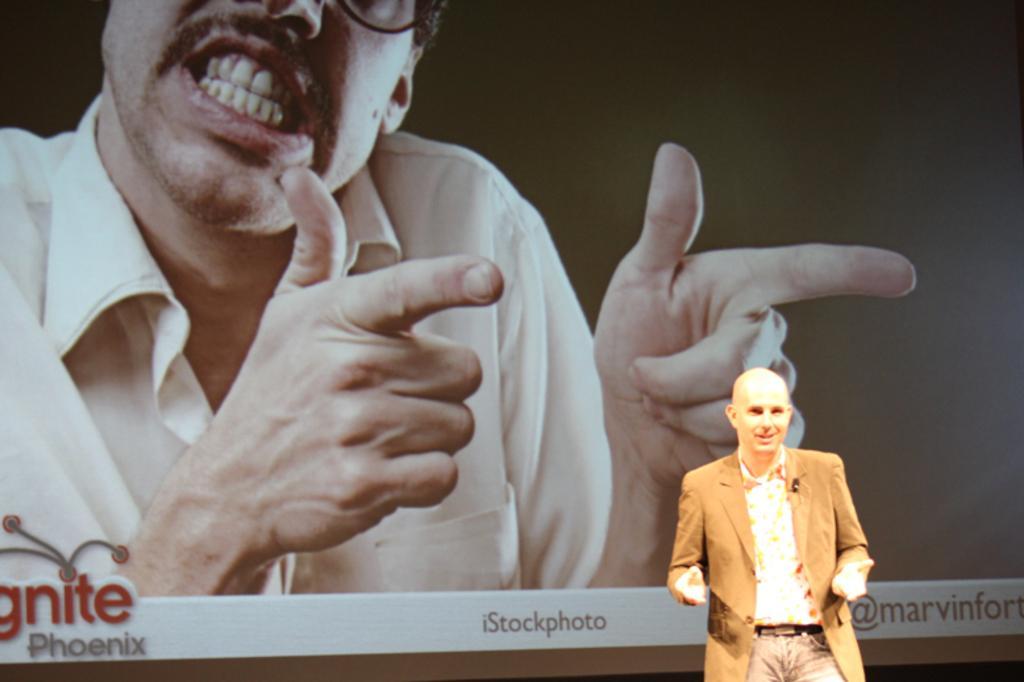In one or two sentences, can you explain what this image depicts? At the bottom right corner a man is standing. In the background of the image a screen is there. On screen we can see a person and some text are there. 